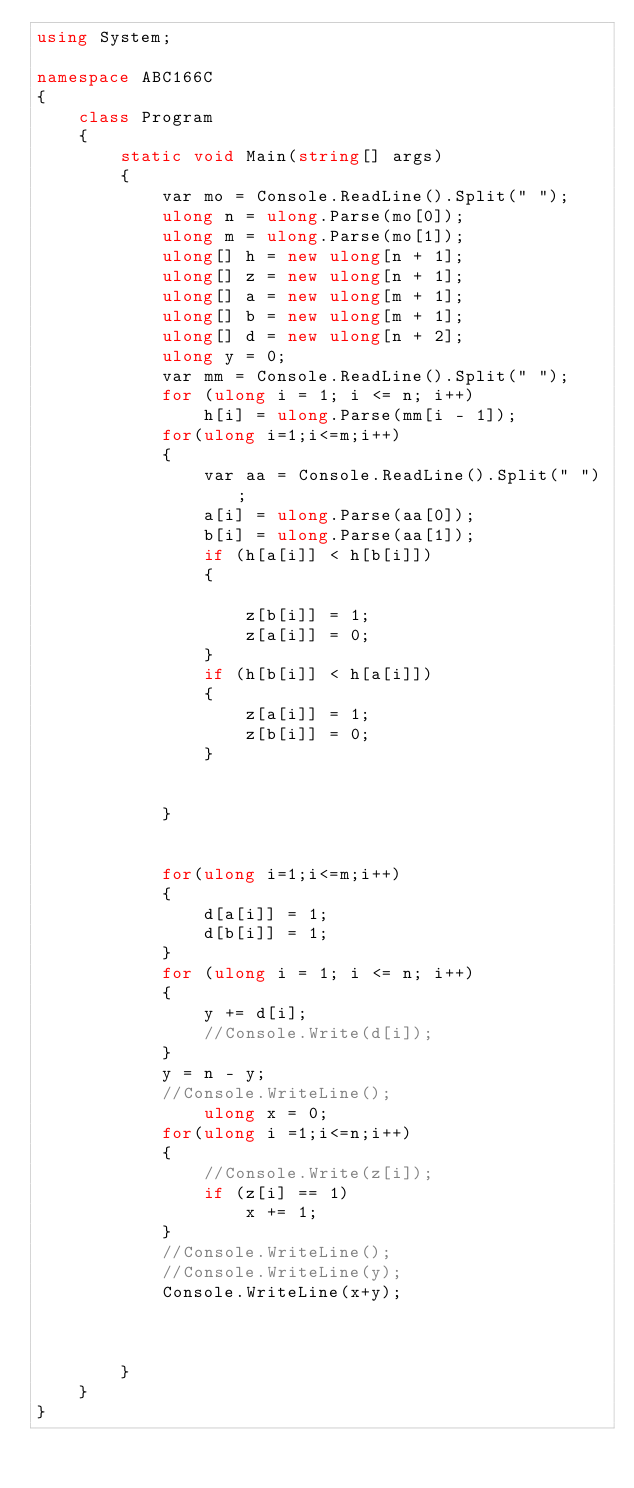<code> <loc_0><loc_0><loc_500><loc_500><_C#_>using System;

namespace ABC166C
{
    class Program
    {
        static void Main(string[] args)
        {
            var mo = Console.ReadLine().Split(" ");
            ulong n = ulong.Parse(mo[0]);
            ulong m = ulong.Parse(mo[1]);
            ulong[] h = new ulong[n + 1];
            ulong[] z = new ulong[n + 1];
            ulong[] a = new ulong[m + 1];
            ulong[] b = new ulong[m + 1];
            ulong[] d = new ulong[n + 2];
            ulong y = 0;
            var mm = Console.ReadLine().Split(" ");
            for (ulong i = 1; i <= n; i++)
                h[i] = ulong.Parse(mm[i - 1]);
            for(ulong i=1;i<=m;i++)
            {
                var aa = Console.ReadLine().Split(" ");
                a[i] = ulong.Parse(aa[0]);
                b[i] = ulong.Parse(aa[1]);
                if (h[a[i]] < h[b[i]])
                {
                   
                    z[b[i]] = 1;
                    z[a[i]] = 0;
                }
                if (h[b[i]] < h[a[i]])
                {
                    z[a[i]] = 1;
                    z[b[i]] = 0;
                }
               

            }


            for(ulong i=1;i<=m;i++)
            {
                d[a[i]] = 1;
                d[b[i]] = 1;
            }
            for (ulong i = 1; i <= n; i++)
            {
                y += d[i];
                //Console.Write(d[i]);
            }
            y = n - y;
            //Console.WriteLine();
                ulong x = 0;
            for(ulong i =1;i<=n;i++)
            {
                //Console.Write(z[i]);
                if (z[i] == 1)
                    x += 1;
            }
            //Console.WriteLine();
            //Console.WriteLine(y);
            Console.WriteLine(x+y);



        }
    }
}
</code> 